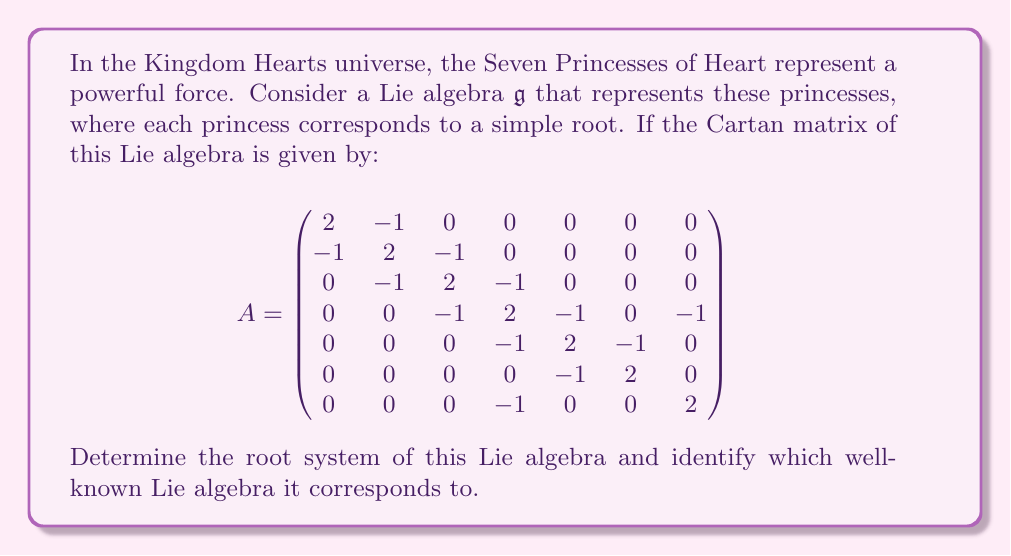Could you help me with this problem? To determine the root system and identify the Lie algebra, we'll follow these steps:

1) First, we need to analyze the Cartan matrix. The matrix is 7x7, indicating that the rank of the Lie algebra is 7, which matches the number of Princesses of Heart.

2) The diagonal elements are all 2, and the off-diagonal elements are either 0 or -1. This is characteristic of simply-laced Lie algebras, where all roots have the same length.

3) To identify the Lie algebra, we need to construct its Dynkin diagram. In a Dynkin diagram:
   - Each simple root is represented by a node
   - Two nodes are connected if the corresponding off-diagonal element in the Cartan matrix is -1
   - The number of lines connecting two nodes is determined by the product of the corresponding off-diagonal elements

4) Constructing the Dynkin diagram based on the given Cartan matrix:

[asy]
unitsize(0.5cm);
for(int i=0; i<7; ++i) {
  draw(circle((i,0),0.5));
  label("$"+(string)(i+1)+"$", (i,0));
}
draw((0.5,0)--(5.5,0));
draw((3,0.5)--(3,-0.5)--(6,-0.5)--(6,0.5));
[/asy]

5) This Dynkin diagram corresponds to the exceptional Lie algebra $E_7$.

6) The root system of $E_7$ consists of:
   - 126 roots in total
   - 63 positive roots (including 7 simple roots)
   - 63 negative roots

7) The simple roots can be expressed in an 8-dimensional space as:
   $\alpha_1 = (1,-1,0,0,0,0,0,0)$
   $\alpha_2 = (0,1,-1,0,0,0,0,0)$
   $\alpha_3 = (0,0,1,-1,0,0,0,0)$
   $\alpha_4 = (0,0,0,1,-1,0,0,0)$
   $\alpha_5 = (0,0,0,0,1,-1,0,0)$
   $\alpha_6 = (0,0,0,0,0,1,-1,0)$
   $\alpha_7 = (\frac{1}{2},\frac{1}{2},\frac{1}{2},\frac{1}{2},\frac{1}{2},\frac{1}{2},\frac{1}{2},\frac{1}{2})$

8) The highest root of $E_7$ is:
   $\theta = 2\alpha_1 + 3\alpha_2 + 4\alpha_3 + 3\alpha_4 + 2\alpha_5 + \alpha_6 + 2\alpha_7$

This root system beautifully represents the Seven Princesses of Heart, with each princess corresponding to a simple root, and their interconnected power represented by the complex structure of the $E_7$ Lie algebra.
Answer: The root system corresponds to the exceptional Lie algebra $E_7$, which has 126 roots in total: 63 positive roots (including 7 simple roots) and 63 negative roots. 